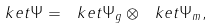Convert formula to latex. <formula><loc_0><loc_0><loc_500><loc_500>\ k e t { \Psi } = \ k e t { \Psi _ { g } } \otimes \ k e t { \Psi _ { m } } ,</formula> 